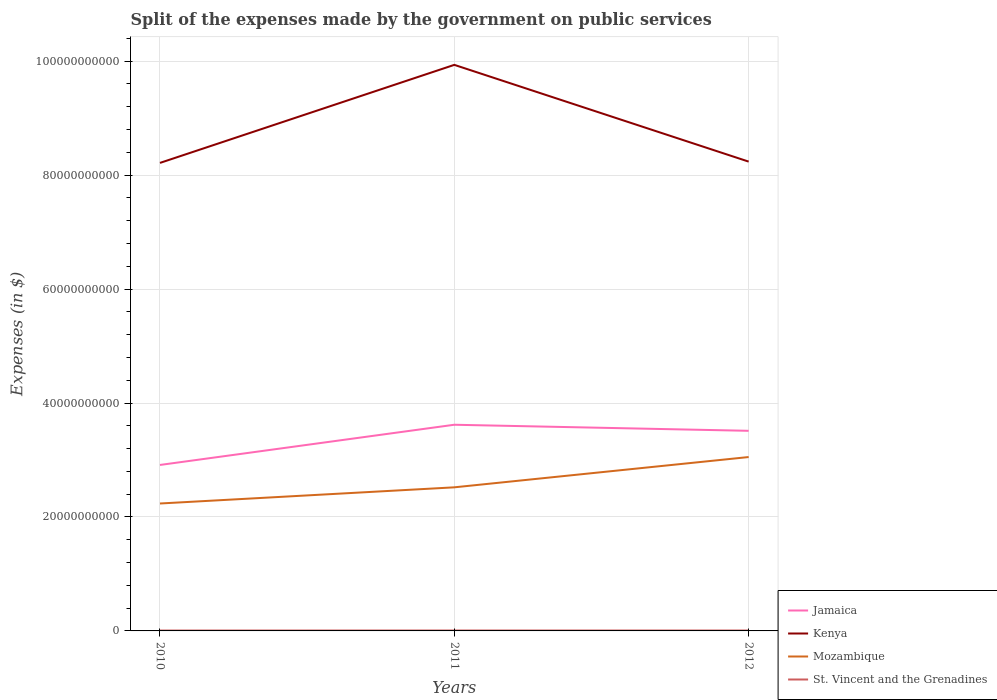How many different coloured lines are there?
Keep it short and to the point. 4. Across all years, what is the maximum expenses made by the government on public services in Kenya?
Your answer should be very brief. 8.22e+1. What is the total expenses made by the government on public services in St. Vincent and the Grenadines in the graph?
Provide a succinct answer. 3.80e+06. What is the difference between the highest and the second highest expenses made by the government on public services in Jamaica?
Your answer should be very brief. 7.06e+09. Is the expenses made by the government on public services in Jamaica strictly greater than the expenses made by the government on public services in Kenya over the years?
Offer a terse response. Yes. How many lines are there?
Provide a short and direct response. 4. How many years are there in the graph?
Provide a succinct answer. 3. What is the difference between two consecutive major ticks on the Y-axis?
Offer a very short reply. 2.00e+1. What is the title of the graph?
Give a very brief answer. Split of the expenses made by the government on public services. Does "Niger" appear as one of the legend labels in the graph?
Offer a very short reply. No. What is the label or title of the Y-axis?
Your answer should be very brief. Expenses (in $). What is the Expenses (in $) in Jamaica in 2010?
Your response must be concise. 2.91e+1. What is the Expenses (in $) in Kenya in 2010?
Your answer should be very brief. 8.22e+1. What is the Expenses (in $) in Mozambique in 2010?
Your response must be concise. 2.24e+1. What is the Expenses (in $) in St. Vincent and the Grenadines in 2010?
Your answer should be very brief. 6.71e+07. What is the Expenses (in $) of Jamaica in 2011?
Give a very brief answer. 3.62e+1. What is the Expenses (in $) in Kenya in 2011?
Ensure brevity in your answer.  9.94e+1. What is the Expenses (in $) of Mozambique in 2011?
Your response must be concise. 2.52e+1. What is the Expenses (in $) of St. Vincent and the Grenadines in 2011?
Your response must be concise. 7.43e+07. What is the Expenses (in $) of Jamaica in 2012?
Give a very brief answer. 3.51e+1. What is the Expenses (in $) of Kenya in 2012?
Provide a succinct answer. 8.24e+1. What is the Expenses (in $) of Mozambique in 2012?
Make the answer very short. 3.05e+1. What is the Expenses (in $) in St. Vincent and the Grenadines in 2012?
Offer a very short reply. 7.05e+07. Across all years, what is the maximum Expenses (in $) of Jamaica?
Give a very brief answer. 3.62e+1. Across all years, what is the maximum Expenses (in $) of Kenya?
Provide a short and direct response. 9.94e+1. Across all years, what is the maximum Expenses (in $) of Mozambique?
Keep it short and to the point. 3.05e+1. Across all years, what is the maximum Expenses (in $) in St. Vincent and the Grenadines?
Keep it short and to the point. 7.43e+07. Across all years, what is the minimum Expenses (in $) in Jamaica?
Provide a short and direct response. 2.91e+1. Across all years, what is the minimum Expenses (in $) of Kenya?
Give a very brief answer. 8.22e+1. Across all years, what is the minimum Expenses (in $) in Mozambique?
Make the answer very short. 2.24e+1. Across all years, what is the minimum Expenses (in $) of St. Vincent and the Grenadines?
Offer a terse response. 6.71e+07. What is the total Expenses (in $) of Jamaica in the graph?
Give a very brief answer. 1.00e+11. What is the total Expenses (in $) in Kenya in the graph?
Make the answer very short. 2.64e+11. What is the total Expenses (in $) in Mozambique in the graph?
Your answer should be very brief. 7.81e+1. What is the total Expenses (in $) of St. Vincent and the Grenadines in the graph?
Keep it short and to the point. 2.12e+08. What is the difference between the Expenses (in $) in Jamaica in 2010 and that in 2011?
Provide a succinct answer. -7.06e+09. What is the difference between the Expenses (in $) in Kenya in 2010 and that in 2011?
Keep it short and to the point. -1.72e+1. What is the difference between the Expenses (in $) in Mozambique in 2010 and that in 2011?
Provide a succinct answer. -2.84e+09. What is the difference between the Expenses (in $) of St. Vincent and the Grenadines in 2010 and that in 2011?
Ensure brevity in your answer.  -7.20e+06. What is the difference between the Expenses (in $) in Jamaica in 2010 and that in 2012?
Offer a very short reply. -5.99e+09. What is the difference between the Expenses (in $) of Kenya in 2010 and that in 2012?
Give a very brief answer. -2.26e+08. What is the difference between the Expenses (in $) in Mozambique in 2010 and that in 2012?
Provide a short and direct response. -8.15e+09. What is the difference between the Expenses (in $) of St. Vincent and the Grenadines in 2010 and that in 2012?
Ensure brevity in your answer.  -3.40e+06. What is the difference between the Expenses (in $) of Jamaica in 2011 and that in 2012?
Provide a succinct answer. 1.06e+09. What is the difference between the Expenses (in $) in Kenya in 2011 and that in 2012?
Provide a short and direct response. 1.70e+1. What is the difference between the Expenses (in $) of Mozambique in 2011 and that in 2012?
Provide a succinct answer. -5.32e+09. What is the difference between the Expenses (in $) of St. Vincent and the Grenadines in 2011 and that in 2012?
Offer a terse response. 3.80e+06. What is the difference between the Expenses (in $) of Jamaica in 2010 and the Expenses (in $) of Kenya in 2011?
Keep it short and to the point. -7.02e+1. What is the difference between the Expenses (in $) of Jamaica in 2010 and the Expenses (in $) of Mozambique in 2011?
Give a very brief answer. 3.93e+09. What is the difference between the Expenses (in $) in Jamaica in 2010 and the Expenses (in $) in St. Vincent and the Grenadines in 2011?
Your response must be concise. 2.91e+1. What is the difference between the Expenses (in $) of Kenya in 2010 and the Expenses (in $) of Mozambique in 2011?
Offer a very short reply. 5.69e+1. What is the difference between the Expenses (in $) in Kenya in 2010 and the Expenses (in $) in St. Vincent and the Grenadines in 2011?
Offer a very short reply. 8.21e+1. What is the difference between the Expenses (in $) of Mozambique in 2010 and the Expenses (in $) of St. Vincent and the Grenadines in 2011?
Your answer should be very brief. 2.23e+1. What is the difference between the Expenses (in $) in Jamaica in 2010 and the Expenses (in $) in Kenya in 2012?
Your answer should be very brief. -5.32e+1. What is the difference between the Expenses (in $) in Jamaica in 2010 and the Expenses (in $) in Mozambique in 2012?
Your response must be concise. -1.39e+09. What is the difference between the Expenses (in $) in Jamaica in 2010 and the Expenses (in $) in St. Vincent and the Grenadines in 2012?
Provide a short and direct response. 2.91e+1. What is the difference between the Expenses (in $) in Kenya in 2010 and the Expenses (in $) in Mozambique in 2012?
Offer a very short reply. 5.16e+1. What is the difference between the Expenses (in $) in Kenya in 2010 and the Expenses (in $) in St. Vincent and the Grenadines in 2012?
Give a very brief answer. 8.21e+1. What is the difference between the Expenses (in $) in Mozambique in 2010 and the Expenses (in $) in St. Vincent and the Grenadines in 2012?
Ensure brevity in your answer.  2.23e+1. What is the difference between the Expenses (in $) in Jamaica in 2011 and the Expenses (in $) in Kenya in 2012?
Keep it short and to the point. -4.62e+1. What is the difference between the Expenses (in $) in Jamaica in 2011 and the Expenses (in $) in Mozambique in 2012?
Ensure brevity in your answer.  5.67e+09. What is the difference between the Expenses (in $) in Jamaica in 2011 and the Expenses (in $) in St. Vincent and the Grenadines in 2012?
Offer a terse response. 3.61e+1. What is the difference between the Expenses (in $) in Kenya in 2011 and the Expenses (in $) in Mozambique in 2012?
Your response must be concise. 6.88e+1. What is the difference between the Expenses (in $) of Kenya in 2011 and the Expenses (in $) of St. Vincent and the Grenadines in 2012?
Make the answer very short. 9.93e+1. What is the difference between the Expenses (in $) of Mozambique in 2011 and the Expenses (in $) of St. Vincent and the Grenadines in 2012?
Ensure brevity in your answer.  2.51e+1. What is the average Expenses (in $) of Jamaica per year?
Your answer should be very brief. 3.35e+1. What is the average Expenses (in $) in Kenya per year?
Ensure brevity in your answer.  8.80e+1. What is the average Expenses (in $) of Mozambique per year?
Keep it short and to the point. 2.60e+1. What is the average Expenses (in $) of St. Vincent and the Grenadines per year?
Provide a short and direct response. 7.06e+07. In the year 2010, what is the difference between the Expenses (in $) in Jamaica and Expenses (in $) in Kenya?
Your answer should be compact. -5.30e+1. In the year 2010, what is the difference between the Expenses (in $) in Jamaica and Expenses (in $) in Mozambique?
Give a very brief answer. 6.77e+09. In the year 2010, what is the difference between the Expenses (in $) in Jamaica and Expenses (in $) in St. Vincent and the Grenadines?
Provide a succinct answer. 2.91e+1. In the year 2010, what is the difference between the Expenses (in $) of Kenya and Expenses (in $) of Mozambique?
Your response must be concise. 5.98e+1. In the year 2010, what is the difference between the Expenses (in $) in Kenya and Expenses (in $) in St. Vincent and the Grenadines?
Give a very brief answer. 8.21e+1. In the year 2010, what is the difference between the Expenses (in $) in Mozambique and Expenses (in $) in St. Vincent and the Grenadines?
Your response must be concise. 2.23e+1. In the year 2011, what is the difference between the Expenses (in $) in Jamaica and Expenses (in $) in Kenya?
Your answer should be compact. -6.32e+1. In the year 2011, what is the difference between the Expenses (in $) of Jamaica and Expenses (in $) of Mozambique?
Your answer should be compact. 1.10e+1. In the year 2011, what is the difference between the Expenses (in $) of Jamaica and Expenses (in $) of St. Vincent and the Grenadines?
Make the answer very short. 3.61e+1. In the year 2011, what is the difference between the Expenses (in $) of Kenya and Expenses (in $) of Mozambique?
Your answer should be very brief. 7.42e+1. In the year 2011, what is the difference between the Expenses (in $) in Kenya and Expenses (in $) in St. Vincent and the Grenadines?
Provide a succinct answer. 9.93e+1. In the year 2011, what is the difference between the Expenses (in $) in Mozambique and Expenses (in $) in St. Vincent and the Grenadines?
Your response must be concise. 2.51e+1. In the year 2012, what is the difference between the Expenses (in $) of Jamaica and Expenses (in $) of Kenya?
Offer a very short reply. -4.73e+1. In the year 2012, what is the difference between the Expenses (in $) in Jamaica and Expenses (in $) in Mozambique?
Give a very brief answer. 4.60e+09. In the year 2012, what is the difference between the Expenses (in $) of Jamaica and Expenses (in $) of St. Vincent and the Grenadines?
Keep it short and to the point. 3.51e+1. In the year 2012, what is the difference between the Expenses (in $) of Kenya and Expenses (in $) of Mozambique?
Make the answer very short. 5.19e+1. In the year 2012, what is the difference between the Expenses (in $) in Kenya and Expenses (in $) in St. Vincent and the Grenadines?
Provide a succinct answer. 8.23e+1. In the year 2012, what is the difference between the Expenses (in $) in Mozambique and Expenses (in $) in St. Vincent and the Grenadines?
Provide a succinct answer. 3.05e+1. What is the ratio of the Expenses (in $) in Jamaica in 2010 to that in 2011?
Offer a terse response. 0.81. What is the ratio of the Expenses (in $) in Kenya in 2010 to that in 2011?
Your answer should be compact. 0.83. What is the ratio of the Expenses (in $) in Mozambique in 2010 to that in 2011?
Your answer should be compact. 0.89. What is the ratio of the Expenses (in $) in St. Vincent and the Grenadines in 2010 to that in 2011?
Your answer should be very brief. 0.9. What is the ratio of the Expenses (in $) in Jamaica in 2010 to that in 2012?
Ensure brevity in your answer.  0.83. What is the ratio of the Expenses (in $) in Kenya in 2010 to that in 2012?
Provide a short and direct response. 1. What is the ratio of the Expenses (in $) in Mozambique in 2010 to that in 2012?
Ensure brevity in your answer.  0.73. What is the ratio of the Expenses (in $) in St. Vincent and the Grenadines in 2010 to that in 2012?
Your answer should be compact. 0.95. What is the ratio of the Expenses (in $) of Jamaica in 2011 to that in 2012?
Give a very brief answer. 1.03. What is the ratio of the Expenses (in $) of Kenya in 2011 to that in 2012?
Offer a terse response. 1.21. What is the ratio of the Expenses (in $) of Mozambique in 2011 to that in 2012?
Give a very brief answer. 0.83. What is the ratio of the Expenses (in $) in St. Vincent and the Grenadines in 2011 to that in 2012?
Offer a very short reply. 1.05. What is the difference between the highest and the second highest Expenses (in $) in Jamaica?
Make the answer very short. 1.06e+09. What is the difference between the highest and the second highest Expenses (in $) in Kenya?
Provide a succinct answer. 1.70e+1. What is the difference between the highest and the second highest Expenses (in $) of Mozambique?
Make the answer very short. 5.32e+09. What is the difference between the highest and the second highest Expenses (in $) of St. Vincent and the Grenadines?
Keep it short and to the point. 3.80e+06. What is the difference between the highest and the lowest Expenses (in $) of Jamaica?
Give a very brief answer. 7.06e+09. What is the difference between the highest and the lowest Expenses (in $) of Kenya?
Provide a succinct answer. 1.72e+1. What is the difference between the highest and the lowest Expenses (in $) of Mozambique?
Offer a very short reply. 8.15e+09. What is the difference between the highest and the lowest Expenses (in $) of St. Vincent and the Grenadines?
Provide a short and direct response. 7.20e+06. 